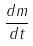<formula> <loc_0><loc_0><loc_500><loc_500>\frac { d m } { d t }</formula> 